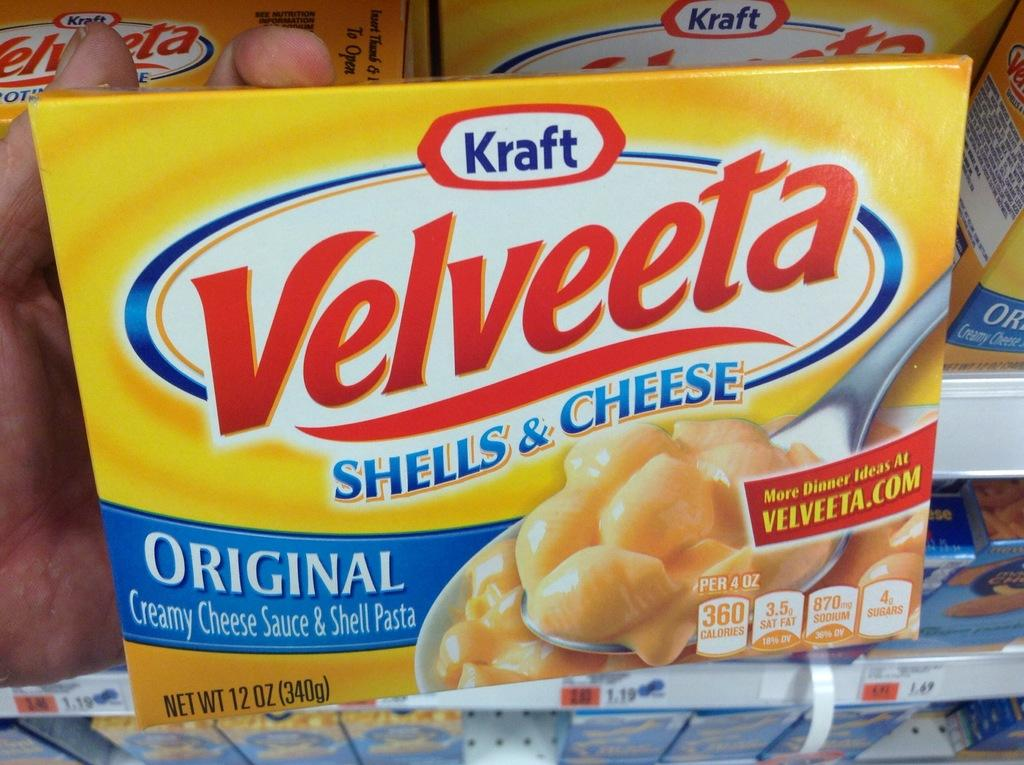What color are the food packets in the image? The food packets in the image are yellow. Where are the food packets located in the image? The food packets are in the middle of the image. What can be seen on the cover of the food packets? There is text on the cover of the food packets. What type of pet is sitting next to the food packets in the image? There is no pet present in the image; it only features the yellow food packets. 